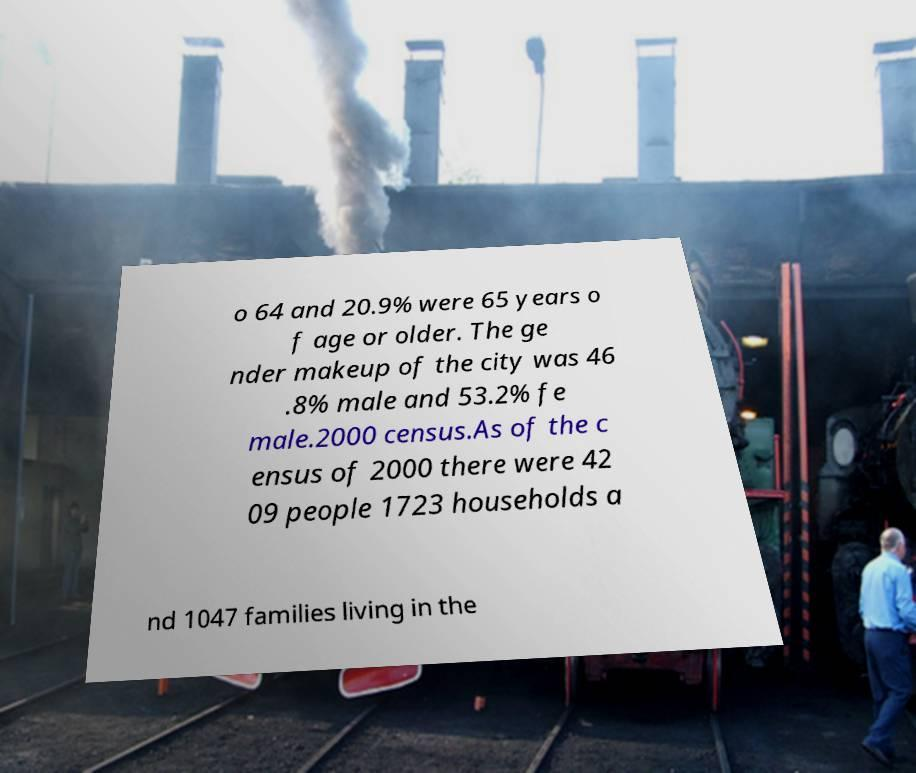I need the written content from this picture converted into text. Can you do that? o 64 and 20.9% were 65 years o f age or older. The ge nder makeup of the city was 46 .8% male and 53.2% fe male.2000 census.As of the c ensus of 2000 there were 42 09 people 1723 households a nd 1047 families living in the 